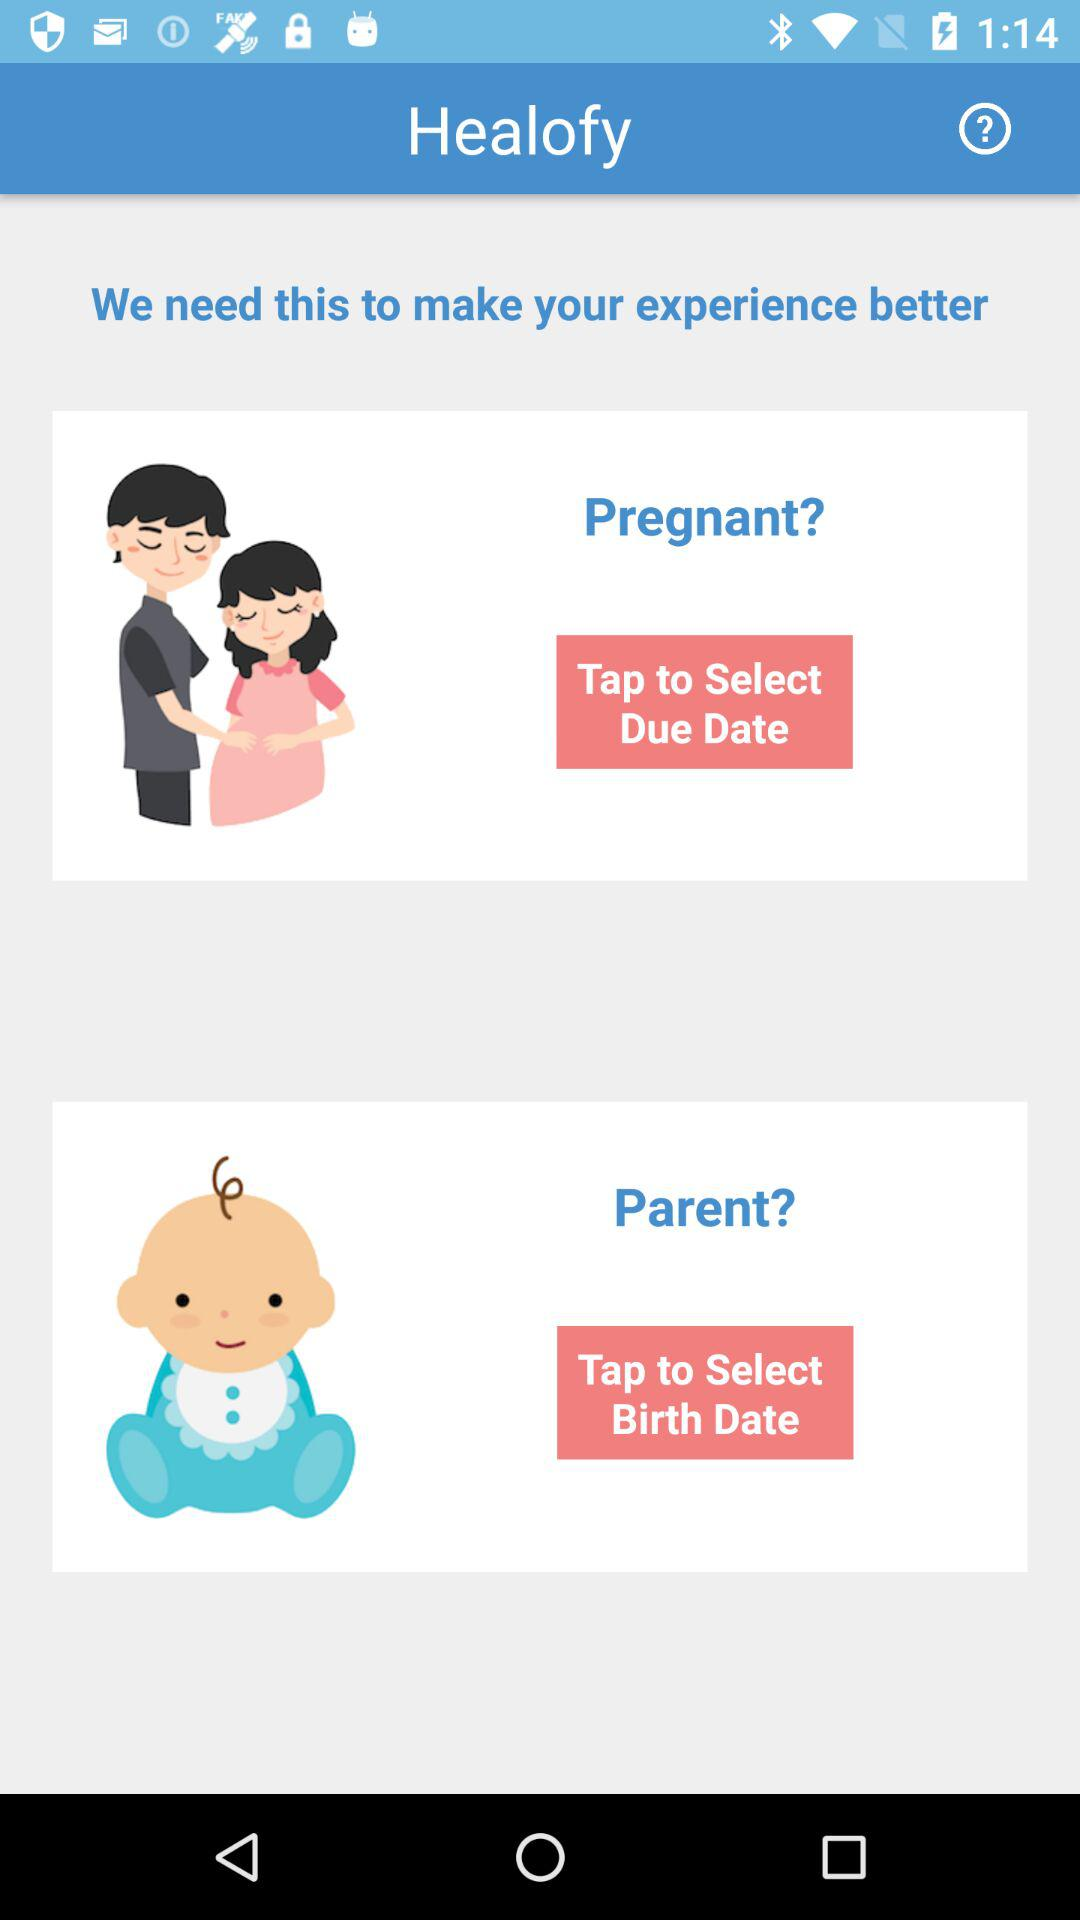What is the name of the application? The name of the application is "Healofy". 